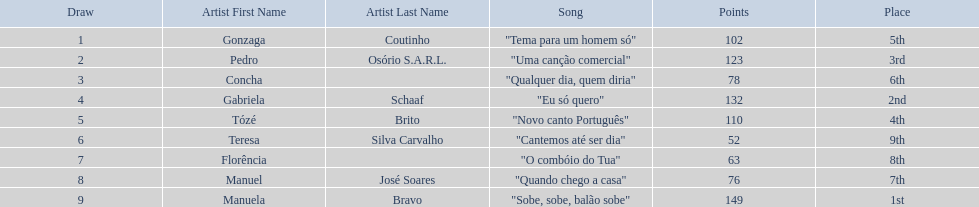Which artists sang in the eurovision song contest of 1979? Gonzaga Coutinho, Pedro Osório S.A.R.L., Concha, Gabriela Schaaf, Tózé Brito, Teresa Silva Carvalho, Florência, Manuel José Soares, Manuela Bravo. Of these, who sang eu so quero? Gabriela Schaaf. 